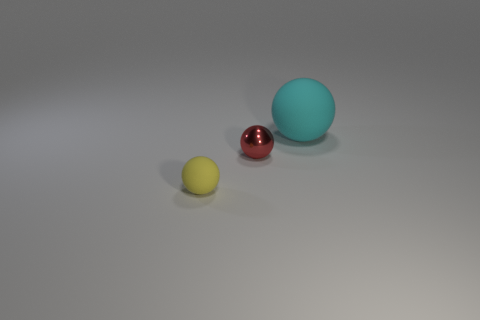Subtract all matte spheres. How many spheres are left? 1 Add 1 yellow cylinders. How many objects exist? 4 Add 1 matte balls. How many matte balls are left? 3 Add 1 big cyan matte balls. How many big cyan matte balls exist? 2 Subtract 0 green blocks. How many objects are left? 3 Subtract 3 spheres. How many spheres are left? 0 Subtract all cyan spheres. Subtract all yellow blocks. How many spheres are left? 2 Subtract all cyan shiny things. Subtract all metal things. How many objects are left? 2 